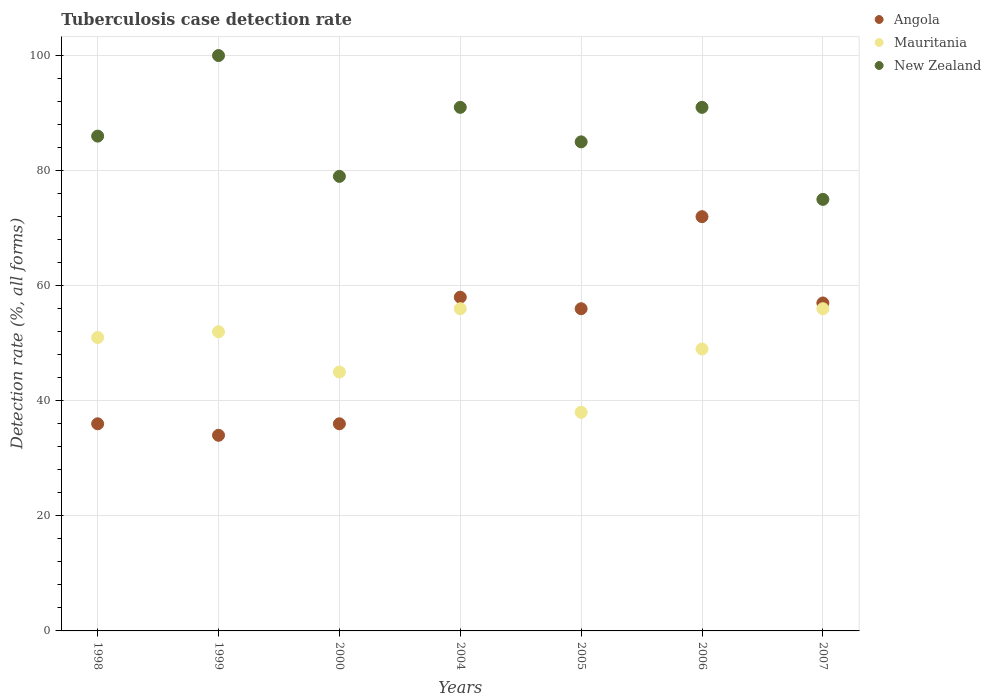What is the tuberculosis case detection rate in in Angola in 1999?
Offer a terse response. 34. Across all years, what is the maximum tuberculosis case detection rate in in Mauritania?
Make the answer very short. 56. Across all years, what is the minimum tuberculosis case detection rate in in New Zealand?
Provide a short and direct response. 75. In which year was the tuberculosis case detection rate in in Mauritania maximum?
Offer a very short reply. 2004. In which year was the tuberculosis case detection rate in in Mauritania minimum?
Your response must be concise. 2005. What is the total tuberculosis case detection rate in in Angola in the graph?
Your answer should be compact. 349. What is the difference between the tuberculosis case detection rate in in Angola in 1998 and the tuberculosis case detection rate in in New Zealand in 1999?
Give a very brief answer. -64. What is the average tuberculosis case detection rate in in Angola per year?
Offer a very short reply. 49.86. In the year 2000, what is the difference between the tuberculosis case detection rate in in New Zealand and tuberculosis case detection rate in in Mauritania?
Keep it short and to the point. 34. In how many years, is the tuberculosis case detection rate in in New Zealand greater than 40 %?
Provide a succinct answer. 7. What is the ratio of the tuberculosis case detection rate in in Angola in 1999 to that in 2007?
Offer a terse response. 0.6. Is the tuberculosis case detection rate in in Mauritania in 1999 less than that in 2006?
Ensure brevity in your answer.  No. Is the difference between the tuberculosis case detection rate in in New Zealand in 1999 and 2005 greater than the difference between the tuberculosis case detection rate in in Mauritania in 1999 and 2005?
Give a very brief answer. Yes. What is the difference between the highest and the second highest tuberculosis case detection rate in in New Zealand?
Keep it short and to the point. 9. What is the difference between the highest and the lowest tuberculosis case detection rate in in New Zealand?
Provide a succinct answer. 25. Is the sum of the tuberculosis case detection rate in in Angola in 1998 and 2006 greater than the maximum tuberculosis case detection rate in in Mauritania across all years?
Keep it short and to the point. Yes. Is the tuberculosis case detection rate in in Mauritania strictly greater than the tuberculosis case detection rate in in Angola over the years?
Give a very brief answer. No. How many years are there in the graph?
Your answer should be very brief. 7. Does the graph contain grids?
Give a very brief answer. Yes. Where does the legend appear in the graph?
Offer a very short reply. Top right. How are the legend labels stacked?
Provide a short and direct response. Vertical. What is the title of the graph?
Make the answer very short. Tuberculosis case detection rate. Does "Somalia" appear as one of the legend labels in the graph?
Provide a succinct answer. No. What is the label or title of the Y-axis?
Offer a terse response. Detection rate (%, all forms). What is the Detection rate (%, all forms) of Mauritania in 1998?
Ensure brevity in your answer.  51. What is the Detection rate (%, all forms) in New Zealand in 1998?
Offer a terse response. 86. What is the Detection rate (%, all forms) in Angola in 1999?
Provide a short and direct response. 34. What is the Detection rate (%, all forms) of Mauritania in 1999?
Offer a very short reply. 52. What is the Detection rate (%, all forms) in New Zealand in 2000?
Make the answer very short. 79. What is the Detection rate (%, all forms) in Angola in 2004?
Provide a succinct answer. 58. What is the Detection rate (%, all forms) of Mauritania in 2004?
Your answer should be very brief. 56. What is the Detection rate (%, all forms) in New Zealand in 2004?
Provide a succinct answer. 91. What is the Detection rate (%, all forms) of Mauritania in 2005?
Your answer should be compact. 38. What is the Detection rate (%, all forms) of New Zealand in 2005?
Provide a short and direct response. 85. What is the Detection rate (%, all forms) of Mauritania in 2006?
Your answer should be very brief. 49. What is the Detection rate (%, all forms) of New Zealand in 2006?
Your answer should be compact. 91. What is the Detection rate (%, all forms) in Angola in 2007?
Your response must be concise. 57. What is the Detection rate (%, all forms) of Mauritania in 2007?
Keep it short and to the point. 56. What is the Detection rate (%, all forms) of New Zealand in 2007?
Provide a succinct answer. 75. Across all years, what is the maximum Detection rate (%, all forms) in Mauritania?
Give a very brief answer. 56. Across all years, what is the maximum Detection rate (%, all forms) of New Zealand?
Provide a succinct answer. 100. Across all years, what is the minimum Detection rate (%, all forms) in Angola?
Your answer should be compact. 34. Across all years, what is the minimum Detection rate (%, all forms) in New Zealand?
Make the answer very short. 75. What is the total Detection rate (%, all forms) of Angola in the graph?
Your answer should be compact. 349. What is the total Detection rate (%, all forms) in Mauritania in the graph?
Keep it short and to the point. 347. What is the total Detection rate (%, all forms) in New Zealand in the graph?
Make the answer very short. 607. What is the difference between the Detection rate (%, all forms) in New Zealand in 1998 and that in 2000?
Provide a short and direct response. 7. What is the difference between the Detection rate (%, all forms) of Angola in 1998 and that in 2004?
Provide a succinct answer. -22. What is the difference between the Detection rate (%, all forms) of New Zealand in 1998 and that in 2004?
Your answer should be very brief. -5. What is the difference between the Detection rate (%, all forms) of Angola in 1998 and that in 2005?
Give a very brief answer. -20. What is the difference between the Detection rate (%, all forms) in Mauritania in 1998 and that in 2005?
Ensure brevity in your answer.  13. What is the difference between the Detection rate (%, all forms) in Angola in 1998 and that in 2006?
Keep it short and to the point. -36. What is the difference between the Detection rate (%, all forms) in Mauritania in 1998 and that in 2006?
Offer a terse response. 2. What is the difference between the Detection rate (%, all forms) of Angola in 1998 and that in 2007?
Make the answer very short. -21. What is the difference between the Detection rate (%, all forms) of Angola in 1999 and that in 2000?
Ensure brevity in your answer.  -2. What is the difference between the Detection rate (%, all forms) in Mauritania in 1999 and that in 2000?
Offer a terse response. 7. What is the difference between the Detection rate (%, all forms) in New Zealand in 1999 and that in 2000?
Make the answer very short. 21. What is the difference between the Detection rate (%, all forms) in Angola in 1999 and that in 2004?
Your answer should be compact. -24. What is the difference between the Detection rate (%, all forms) of New Zealand in 1999 and that in 2005?
Your answer should be compact. 15. What is the difference between the Detection rate (%, all forms) of Angola in 1999 and that in 2006?
Ensure brevity in your answer.  -38. What is the difference between the Detection rate (%, all forms) in New Zealand in 1999 and that in 2006?
Your answer should be very brief. 9. What is the difference between the Detection rate (%, all forms) in Angola in 2000 and that in 2004?
Make the answer very short. -22. What is the difference between the Detection rate (%, all forms) of Angola in 2000 and that in 2005?
Make the answer very short. -20. What is the difference between the Detection rate (%, all forms) of Mauritania in 2000 and that in 2005?
Your answer should be compact. 7. What is the difference between the Detection rate (%, all forms) in Angola in 2000 and that in 2006?
Your response must be concise. -36. What is the difference between the Detection rate (%, all forms) in Mauritania in 2000 and that in 2006?
Offer a very short reply. -4. What is the difference between the Detection rate (%, all forms) in New Zealand in 2000 and that in 2006?
Offer a very short reply. -12. What is the difference between the Detection rate (%, all forms) in Mauritania in 2000 and that in 2007?
Offer a terse response. -11. What is the difference between the Detection rate (%, all forms) in Mauritania in 2004 and that in 2005?
Give a very brief answer. 18. What is the difference between the Detection rate (%, all forms) in Mauritania in 2004 and that in 2006?
Offer a terse response. 7. What is the difference between the Detection rate (%, all forms) in Angola in 2004 and that in 2007?
Keep it short and to the point. 1. What is the difference between the Detection rate (%, all forms) of Mauritania in 2004 and that in 2007?
Ensure brevity in your answer.  0. What is the difference between the Detection rate (%, all forms) of New Zealand in 2004 and that in 2007?
Offer a terse response. 16. What is the difference between the Detection rate (%, all forms) of Angola in 2005 and that in 2007?
Offer a terse response. -1. What is the difference between the Detection rate (%, all forms) of New Zealand in 2005 and that in 2007?
Your answer should be compact. 10. What is the difference between the Detection rate (%, all forms) of Mauritania in 2006 and that in 2007?
Your answer should be very brief. -7. What is the difference between the Detection rate (%, all forms) of Angola in 1998 and the Detection rate (%, all forms) of New Zealand in 1999?
Provide a short and direct response. -64. What is the difference between the Detection rate (%, all forms) in Mauritania in 1998 and the Detection rate (%, all forms) in New Zealand in 1999?
Offer a very short reply. -49. What is the difference between the Detection rate (%, all forms) of Angola in 1998 and the Detection rate (%, all forms) of Mauritania in 2000?
Make the answer very short. -9. What is the difference between the Detection rate (%, all forms) in Angola in 1998 and the Detection rate (%, all forms) in New Zealand in 2000?
Provide a succinct answer. -43. What is the difference between the Detection rate (%, all forms) of Angola in 1998 and the Detection rate (%, all forms) of Mauritania in 2004?
Provide a short and direct response. -20. What is the difference between the Detection rate (%, all forms) of Angola in 1998 and the Detection rate (%, all forms) of New Zealand in 2004?
Provide a short and direct response. -55. What is the difference between the Detection rate (%, all forms) of Angola in 1998 and the Detection rate (%, all forms) of Mauritania in 2005?
Provide a succinct answer. -2. What is the difference between the Detection rate (%, all forms) of Angola in 1998 and the Detection rate (%, all forms) of New Zealand in 2005?
Your answer should be compact. -49. What is the difference between the Detection rate (%, all forms) in Mauritania in 1998 and the Detection rate (%, all forms) in New Zealand in 2005?
Make the answer very short. -34. What is the difference between the Detection rate (%, all forms) of Angola in 1998 and the Detection rate (%, all forms) of Mauritania in 2006?
Keep it short and to the point. -13. What is the difference between the Detection rate (%, all forms) of Angola in 1998 and the Detection rate (%, all forms) of New Zealand in 2006?
Ensure brevity in your answer.  -55. What is the difference between the Detection rate (%, all forms) in Mauritania in 1998 and the Detection rate (%, all forms) in New Zealand in 2006?
Offer a very short reply. -40. What is the difference between the Detection rate (%, all forms) in Angola in 1998 and the Detection rate (%, all forms) in Mauritania in 2007?
Your response must be concise. -20. What is the difference between the Detection rate (%, all forms) of Angola in 1998 and the Detection rate (%, all forms) of New Zealand in 2007?
Your answer should be very brief. -39. What is the difference between the Detection rate (%, all forms) of Angola in 1999 and the Detection rate (%, all forms) of New Zealand in 2000?
Ensure brevity in your answer.  -45. What is the difference between the Detection rate (%, all forms) of Mauritania in 1999 and the Detection rate (%, all forms) of New Zealand in 2000?
Ensure brevity in your answer.  -27. What is the difference between the Detection rate (%, all forms) of Angola in 1999 and the Detection rate (%, all forms) of Mauritania in 2004?
Give a very brief answer. -22. What is the difference between the Detection rate (%, all forms) of Angola in 1999 and the Detection rate (%, all forms) of New Zealand in 2004?
Make the answer very short. -57. What is the difference between the Detection rate (%, all forms) in Mauritania in 1999 and the Detection rate (%, all forms) in New Zealand in 2004?
Make the answer very short. -39. What is the difference between the Detection rate (%, all forms) in Angola in 1999 and the Detection rate (%, all forms) in Mauritania in 2005?
Ensure brevity in your answer.  -4. What is the difference between the Detection rate (%, all forms) of Angola in 1999 and the Detection rate (%, all forms) of New Zealand in 2005?
Ensure brevity in your answer.  -51. What is the difference between the Detection rate (%, all forms) in Mauritania in 1999 and the Detection rate (%, all forms) in New Zealand in 2005?
Keep it short and to the point. -33. What is the difference between the Detection rate (%, all forms) of Angola in 1999 and the Detection rate (%, all forms) of Mauritania in 2006?
Keep it short and to the point. -15. What is the difference between the Detection rate (%, all forms) in Angola in 1999 and the Detection rate (%, all forms) in New Zealand in 2006?
Provide a short and direct response. -57. What is the difference between the Detection rate (%, all forms) in Mauritania in 1999 and the Detection rate (%, all forms) in New Zealand in 2006?
Offer a terse response. -39. What is the difference between the Detection rate (%, all forms) in Angola in 1999 and the Detection rate (%, all forms) in New Zealand in 2007?
Provide a succinct answer. -41. What is the difference between the Detection rate (%, all forms) of Mauritania in 1999 and the Detection rate (%, all forms) of New Zealand in 2007?
Give a very brief answer. -23. What is the difference between the Detection rate (%, all forms) of Angola in 2000 and the Detection rate (%, all forms) of New Zealand in 2004?
Ensure brevity in your answer.  -55. What is the difference between the Detection rate (%, all forms) of Mauritania in 2000 and the Detection rate (%, all forms) of New Zealand in 2004?
Offer a very short reply. -46. What is the difference between the Detection rate (%, all forms) of Angola in 2000 and the Detection rate (%, all forms) of Mauritania in 2005?
Give a very brief answer. -2. What is the difference between the Detection rate (%, all forms) of Angola in 2000 and the Detection rate (%, all forms) of New Zealand in 2005?
Offer a very short reply. -49. What is the difference between the Detection rate (%, all forms) of Angola in 2000 and the Detection rate (%, all forms) of Mauritania in 2006?
Ensure brevity in your answer.  -13. What is the difference between the Detection rate (%, all forms) of Angola in 2000 and the Detection rate (%, all forms) of New Zealand in 2006?
Provide a succinct answer. -55. What is the difference between the Detection rate (%, all forms) in Mauritania in 2000 and the Detection rate (%, all forms) in New Zealand in 2006?
Your answer should be compact. -46. What is the difference between the Detection rate (%, all forms) in Angola in 2000 and the Detection rate (%, all forms) in New Zealand in 2007?
Offer a very short reply. -39. What is the difference between the Detection rate (%, all forms) in Angola in 2004 and the Detection rate (%, all forms) in New Zealand in 2005?
Your response must be concise. -27. What is the difference between the Detection rate (%, all forms) of Angola in 2004 and the Detection rate (%, all forms) of New Zealand in 2006?
Provide a short and direct response. -33. What is the difference between the Detection rate (%, all forms) in Mauritania in 2004 and the Detection rate (%, all forms) in New Zealand in 2006?
Your answer should be very brief. -35. What is the difference between the Detection rate (%, all forms) of Angola in 2004 and the Detection rate (%, all forms) of Mauritania in 2007?
Keep it short and to the point. 2. What is the difference between the Detection rate (%, all forms) of Angola in 2005 and the Detection rate (%, all forms) of New Zealand in 2006?
Provide a short and direct response. -35. What is the difference between the Detection rate (%, all forms) in Mauritania in 2005 and the Detection rate (%, all forms) in New Zealand in 2006?
Your answer should be very brief. -53. What is the difference between the Detection rate (%, all forms) of Mauritania in 2005 and the Detection rate (%, all forms) of New Zealand in 2007?
Make the answer very short. -37. What is the difference between the Detection rate (%, all forms) in Angola in 2006 and the Detection rate (%, all forms) in New Zealand in 2007?
Offer a terse response. -3. What is the average Detection rate (%, all forms) in Angola per year?
Your answer should be compact. 49.86. What is the average Detection rate (%, all forms) in Mauritania per year?
Make the answer very short. 49.57. What is the average Detection rate (%, all forms) in New Zealand per year?
Keep it short and to the point. 86.71. In the year 1998, what is the difference between the Detection rate (%, all forms) of Angola and Detection rate (%, all forms) of Mauritania?
Your answer should be compact. -15. In the year 1998, what is the difference between the Detection rate (%, all forms) of Angola and Detection rate (%, all forms) of New Zealand?
Offer a terse response. -50. In the year 1998, what is the difference between the Detection rate (%, all forms) in Mauritania and Detection rate (%, all forms) in New Zealand?
Your answer should be very brief. -35. In the year 1999, what is the difference between the Detection rate (%, all forms) of Angola and Detection rate (%, all forms) of New Zealand?
Give a very brief answer. -66. In the year 1999, what is the difference between the Detection rate (%, all forms) of Mauritania and Detection rate (%, all forms) of New Zealand?
Your response must be concise. -48. In the year 2000, what is the difference between the Detection rate (%, all forms) of Angola and Detection rate (%, all forms) of New Zealand?
Offer a terse response. -43. In the year 2000, what is the difference between the Detection rate (%, all forms) in Mauritania and Detection rate (%, all forms) in New Zealand?
Make the answer very short. -34. In the year 2004, what is the difference between the Detection rate (%, all forms) in Angola and Detection rate (%, all forms) in New Zealand?
Provide a succinct answer. -33. In the year 2004, what is the difference between the Detection rate (%, all forms) of Mauritania and Detection rate (%, all forms) of New Zealand?
Give a very brief answer. -35. In the year 2005, what is the difference between the Detection rate (%, all forms) in Angola and Detection rate (%, all forms) in Mauritania?
Your answer should be very brief. 18. In the year 2005, what is the difference between the Detection rate (%, all forms) in Mauritania and Detection rate (%, all forms) in New Zealand?
Provide a short and direct response. -47. In the year 2006, what is the difference between the Detection rate (%, all forms) of Angola and Detection rate (%, all forms) of New Zealand?
Provide a short and direct response. -19. In the year 2006, what is the difference between the Detection rate (%, all forms) in Mauritania and Detection rate (%, all forms) in New Zealand?
Your answer should be very brief. -42. In the year 2007, what is the difference between the Detection rate (%, all forms) of Mauritania and Detection rate (%, all forms) of New Zealand?
Make the answer very short. -19. What is the ratio of the Detection rate (%, all forms) in Angola in 1998 to that in 1999?
Offer a very short reply. 1.06. What is the ratio of the Detection rate (%, all forms) in Mauritania in 1998 to that in 1999?
Keep it short and to the point. 0.98. What is the ratio of the Detection rate (%, all forms) in New Zealand in 1998 to that in 1999?
Provide a succinct answer. 0.86. What is the ratio of the Detection rate (%, all forms) of Angola in 1998 to that in 2000?
Offer a terse response. 1. What is the ratio of the Detection rate (%, all forms) of Mauritania in 1998 to that in 2000?
Your response must be concise. 1.13. What is the ratio of the Detection rate (%, all forms) of New Zealand in 1998 to that in 2000?
Offer a terse response. 1.09. What is the ratio of the Detection rate (%, all forms) in Angola in 1998 to that in 2004?
Your answer should be compact. 0.62. What is the ratio of the Detection rate (%, all forms) of Mauritania in 1998 to that in 2004?
Make the answer very short. 0.91. What is the ratio of the Detection rate (%, all forms) in New Zealand in 1998 to that in 2004?
Your answer should be very brief. 0.95. What is the ratio of the Detection rate (%, all forms) of Angola in 1998 to that in 2005?
Provide a succinct answer. 0.64. What is the ratio of the Detection rate (%, all forms) of Mauritania in 1998 to that in 2005?
Ensure brevity in your answer.  1.34. What is the ratio of the Detection rate (%, all forms) in New Zealand in 1998 to that in 2005?
Offer a terse response. 1.01. What is the ratio of the Detection rate (%, all forms) in Mauritania in 1998 to that in 2006?
Offer a terse response. 1.04. What is the ratio of the Detection rate (%, all forms) in New Zealand in 1998 to that in 2006?
Your response must be concise. 0.95. What is the ratio of the Detection rate (%, all forms) of Angola in 1998 to that in 2007?
Make the answer very short. 0.63. What is the ratio of the Detection rate (%, all forms) in Mauritania in 1998 to that in 2007?
Make the answer very short. 0.91. What is the ratio of the Detection rate (%, all forms) of New Zealand in 1998 to that in 2007?
Offer a terse response. 1.15. What is the ratio of the Detection rate (%, all forms) in Angola in 1999 to that in 2000?
Offer a terse response. 0.94. What is the ratio of the Detection rate (%, all forms) in Mauritania in 1999 to that in 2000?
Ensure brevity in your answer.  1.16. What is the ratio of the Detection rate (%, all forms) in New Zealand in 1999 to that in 2000?
Provide a short and direct response. 1.27. What is the ratio of the Detection rate (%, all forms) of Angola in 1999 to that in 2004?
Provide a short and direct response. 0.59. What is the ratio of the Detection rate (%, all forms) in Mauritania in 1999 to that in 2004?
Offer a very short reply. 0.93. What is the ratio of the Detection rate (%, all forms) of New Zealand in 1999 to that in 2004?
Give a very brief answer. 1.1. What is the ratio of the Detection rate (%, all forms) of Angola in 1999 to that in 2005?
Make the answer very short. 0.61. What is the ratio of the Detection rate (%, all forms) of Mauritania in 1999 to that in 2005?
Give a very brief answer. 1.37. What is the ratio of the Detection rate (%, all forms) of New Zealand in 1999 to that in 2005?
Offer a terse response. 1.18. What is the ratio of the Detection rate (%, all forms) of Angola in 1999 to that in 2006?
Your answer should be very brief. 0.47. What is the ratio of the Detection rate (%, all forms) in Mauritania in 1999 to that in 2006?
Give a very brief answer. 1.06. What is the ratio of the Detection rate (%, all forms) of New Zealand in 1999 to that in 2006?
Keep it short and to the point. 1.1. What is the ratio of the Detection rate (%, all forms) in Angola in 1999 to that in 2007?
Keep it short and to the point. 0.6. What is the ratio of the Detection rate (%, all forms) in Mauritania in 1999 to that in 2007?
Your response must be concise. 0.93. What is the ratio of the Detection rate (%, all forms) in Angola in 2000 to that in 2004?
Provide a succinct answer. 0.62. What is the ratio of the Detection rate (%, all forms) of Mauritania in 2000 to that in 2004?
Offer a very short reply. 0.8. What is the ratio of the Detection rate (%, all forms) of New Zealand in 2000 to that in 2004?
Offer a terse response. 0.87. What is the ratio of the Detection rate (%, all forms) of Angola in 2000 to that in 2005?
Your answer should be compact. 0.64. What is the ratio of the Detection rate (%, all forms) in Mauritania in 2000 to that in 2005?
Your answer should be compact. 1.18. What is the ratio of the Detection rate (%, all forms) in New Zealand in 2000 to that in 2005?
Offer a very short reply. 0.93. What is the ratio of the Detection rate (%, all forms) of Angola in 2000 to that in 2006?
Your response must be concise. 0.5. What is the ratio of the Detection rate (%, all forms) in Mauritania in 2000 to that in 2006?
Provide a short and direct response. 0.92. What is the ratio of the Detection rate (%, all forms) in New Zealand in 2000 to that in 2006?
Provide a succinct answer. 0.87. What is the ratio of the Detection rate (%, all forms) of Angola in 2000 to that in 2007?
Provide a short and direct response. 0.63. What is the ratio of the Detection rate (%, all forms) in Mauritania in 2000 to that in 2007?
Offer a terse response. 0.8. What is the ratio of the Detection rate (%, all forms) of New Zealand in 2000 to that in 2007?
Keep it short and to the point. 1.05. What is the ratio of the Detection rate (%, all forms) in Angola in 2004 to that in 2005?
Your answer should be compact. 1.04. What is the ratio of the Detection rate (%, all forms) of Mauritania in 2004 to that in 2005?
Make the answer very short. 1.47. What is the ratio of the Detection rate (%, all forms) of New Zealand in 2004 to that in 2005?
Your answer should be compact. 1.07. What is the ratio of the Detection rate (%, all forms) in Angola in 2004 to that in 2006?
Offer a terse response. 0.81. What is the ratio of the Detection rate (%, all forms) in Angola in 2004 to that in 2007?
Provide a short and direct response. 1.02. What is the ratio of the Detection rate (%, all forms) in Mauritania in 2004 to that in 2007?
Ensure brevity in your answer.  1. What is the ratio of the Detection rate (%, all forms) in New Zealand in 2004 to that in 2007?
Keep it short and to the point. 1.21. What is the ratio of the Detection rate (%, all forms) of Mauritania in 2005 to that in 2006?
Ensure brevity in your answer.  0.78. What is the ratio of the Detection rate (%, all forms) in New Zealand in 2005 to that in 2006?
Make the answer very short. 0.93. What is the ratio of the Detection rate (%, all forms) in Angola in 2005 to that in 2007?
Make the answer very short. 0.98. What is the ratio of the Detection rate (%, all forms) of Mauritania in 2005 to that in 2007?
Give a very brief answer. 0.68. What is the ratio of the Detection rate (%, all forms) of New Zealand in 2005 to that in 2007?
Provide a succinct answer. 1.13. What is the ratio of the Detection rate (%, all forms) in Angola in 2006 to that in 2007?
Provide a short and direct response. 1.26. What is the ratio of the Detection rate (%, all forms) of New Zealand in 2006 to that in 2007?
Provide a short and direct response. 1.21. 